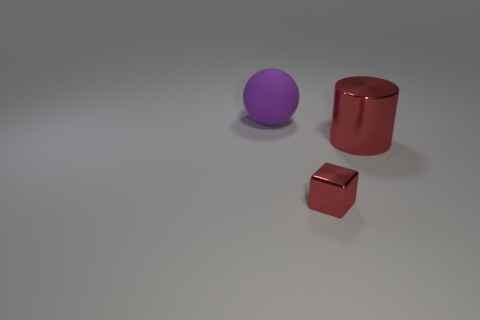What textures can be observed on the surfaces of the objects? The sphere appears to have a smooth, matte finish, while the smaller cube and large cylinder show reflective, slightly glossy textures, indicating that the surface qualities differ among the objects. 